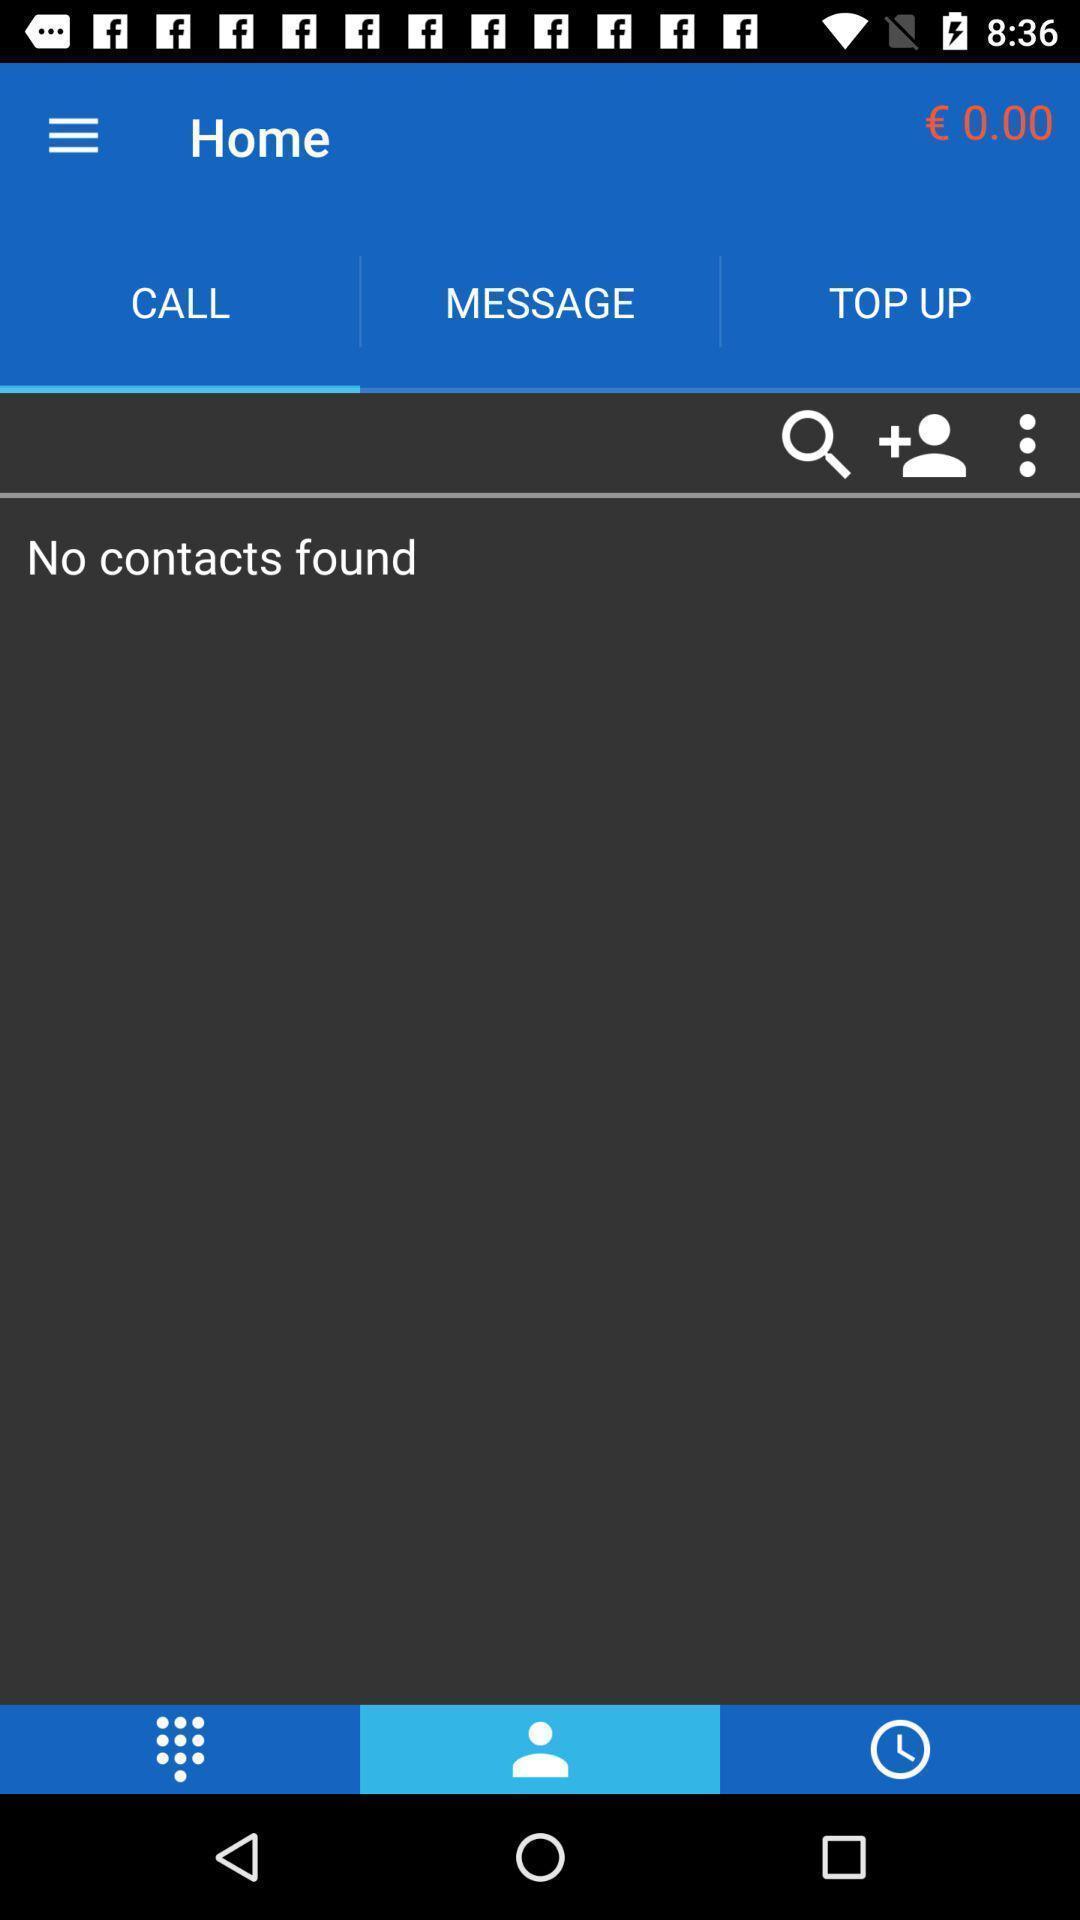Describe the key features of this screenshot. Screen shows call information in a calls app. 